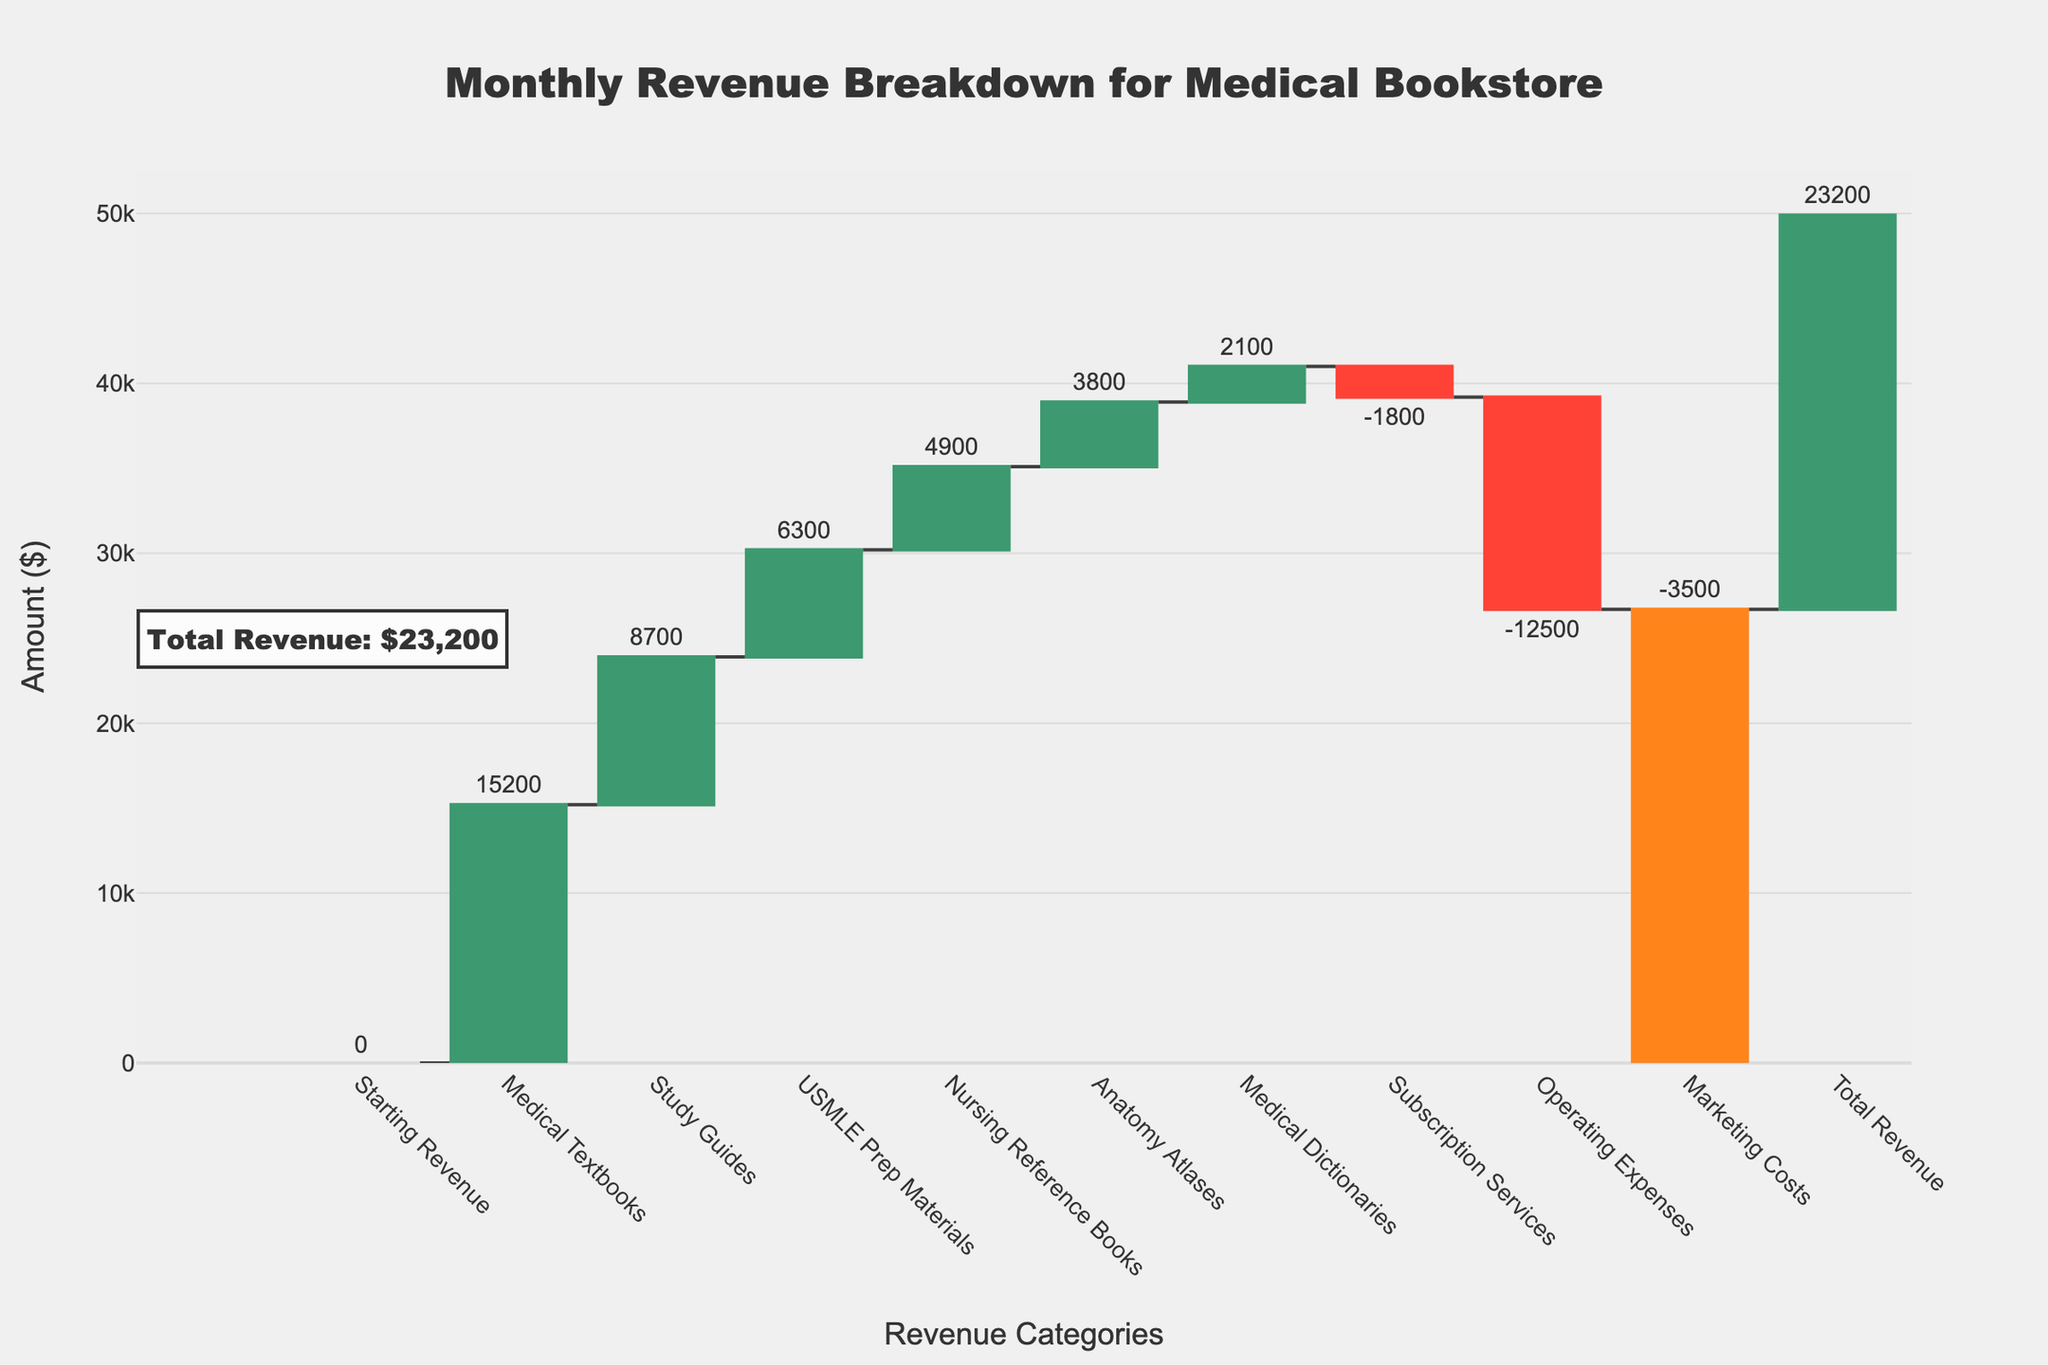what is the title of the chart? The title is at the top of the chart and reads "Monthly Revenue Breakdown for Medical Bookstore."
Answer: Monthly Revenue Breakdown for Medical Bookstore How many total categories are represented in the chart, including both revenue and expense items? Count the number of labeled bars on the x-axis. There are 10 categories displayed.
Answer: 10 What's the total revenue? The bar labeled "Total Revenue" shows a value of $23,200.
Answer: $23,200 Which category contributes the highest revenue? Compare the height of all the bars labeled as revenue categories. The "Medical Textbooks" bar is the tallest.
Answer: Medical Textbooks How much revenue does the USMLE Prep Materials category generate? Refer to the bar labeled "USMLE Prep Materials" which shows $6,300.
Answer: $6,300 What is the total revenue generated from all study-related materials (Medical Textbooks, Study Guides, USMLE Prep Materials, Nursing Reference Books, Anatomy Atlases, Medical Dictionaries)? Sum up the values of the respective categories: 15200 + 8700 + 6300 + 4900 + 3800 + 2100 = $40,000.
Answer: $40,000 What is the net change in revenue from subscription services and operating expenses combined? Sum the values for both categories: -1800 (Subscription Services) + -12500 (Operating Expenses) = -14300.
Answer: -14300 How does the revenue from study guides compare to that from nursing reference books? Compare the bar lengths: Study Guides generate $8,700 whereas Nursing Reference Books generate $4,900.
Answer: Study Guides generate $3,800 more What is the overall impact of expenses on the net revenue? Sum the values of all expense categories: -1800 (Subscription Services) - 12500 (Operating Expenses) - 3500 (Marketing Costs) = -17800.
Answer: -17800 What's the percentage contribution of Medical Textbooks revenue to the total revenue? Divide the Medical Textbooks revenue by the Total Revenue and multiply by 100: (15200 / 23200) * 100 ≈ 65.52%.
Answer: ≈ 65.52% 